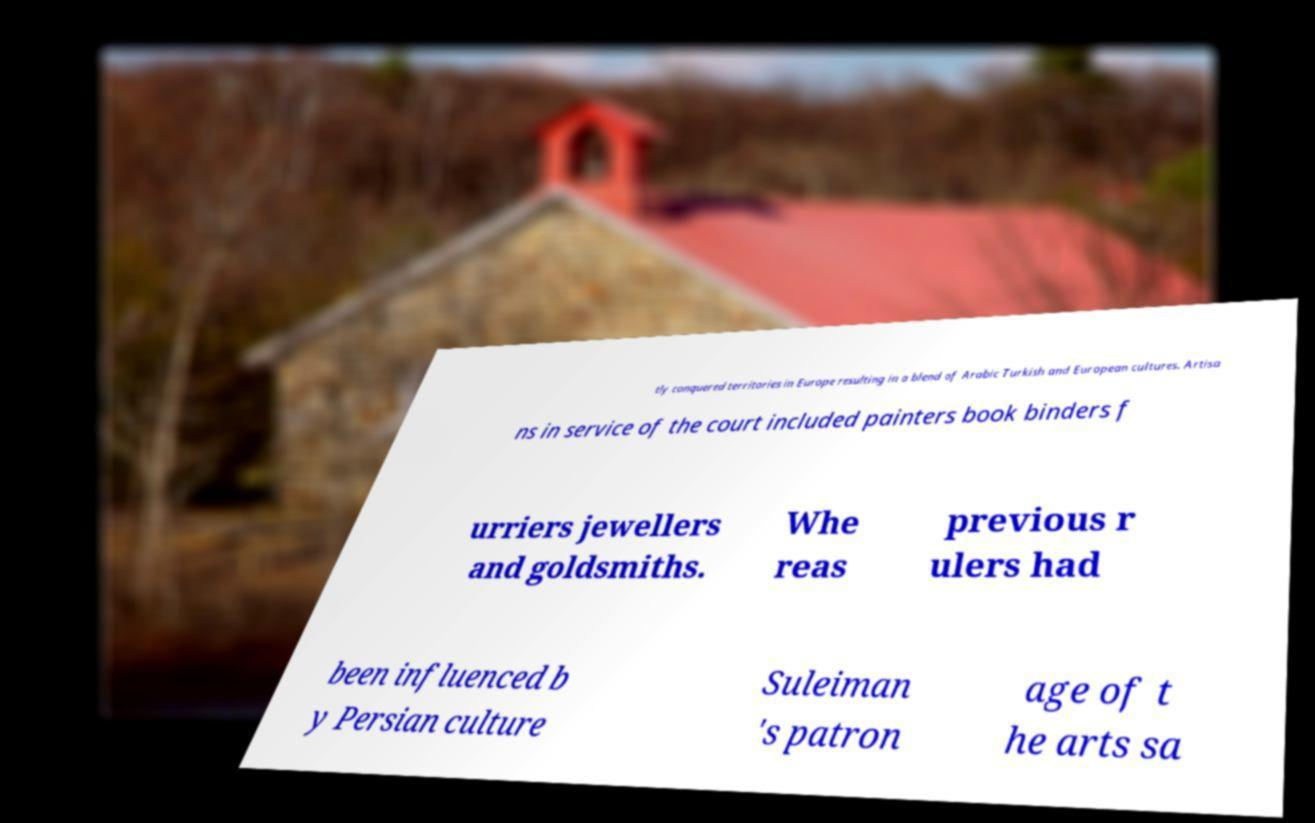Can you read and provide the text displayed in the image?This photo seems to have some interesting text. Can you extract and type it out for me? tly conquered territories in Europe resulting in a blend of Arabic Turkish and European cultures. Artisa ns in service of the court included painters book binders f urriers jewellers and goldsmiths. Whe reas previous r ulers had been influenced b y Persian culture Suleiman 's patron age of t he arts sa 